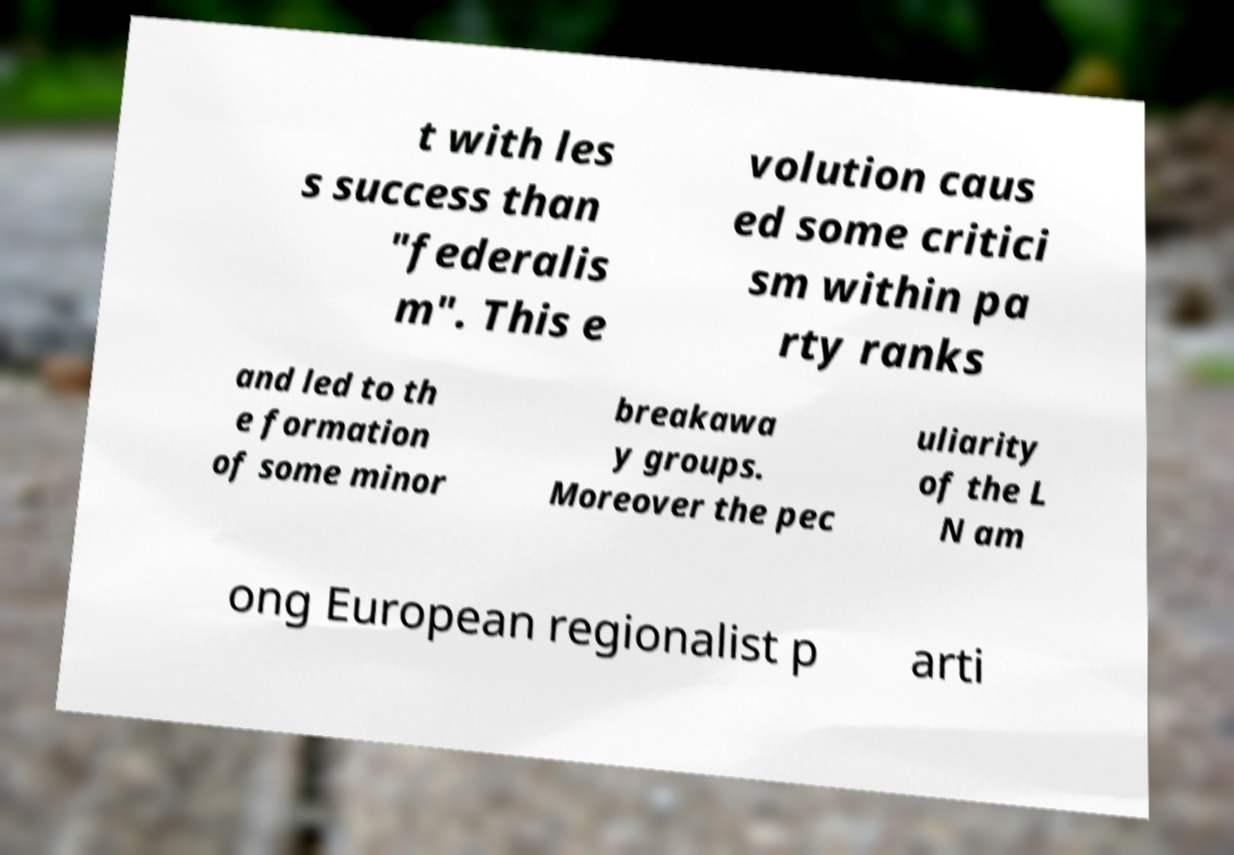Please identify and transcribe the text found in this image. t with les s success than "federalis m". This e volution caus ed some critici sm within pa rty ranks and led to th e formation of some minor breakawa y groups. Moreover the pec uliarity of the L N am ong European regionalist p arti 